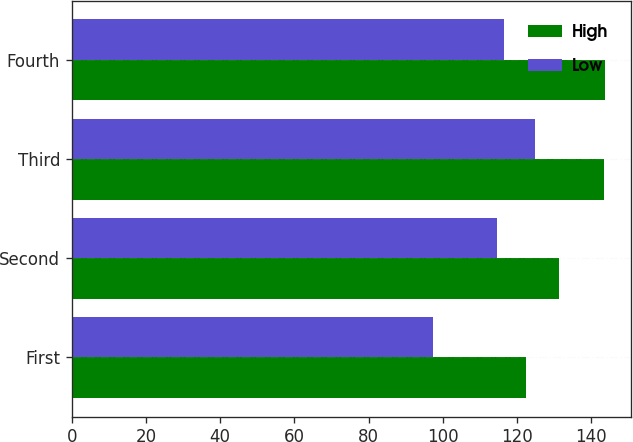Convert chart to OTSL. <chart><loc_0><loc_0><loc_500><loc_500><stacked_bar_chart><ecel><fcel>First<fcel>Second<fcel>Third<fcel>Fourth<nl><fcel>High<fcel>122.38<fcel>131.3<fcel>143.43<fcel>143.64<nl><fcel>Low<fcel>97.24<fcel>114.65<fcel>124.77<fcel>116.64<nl></chart> 